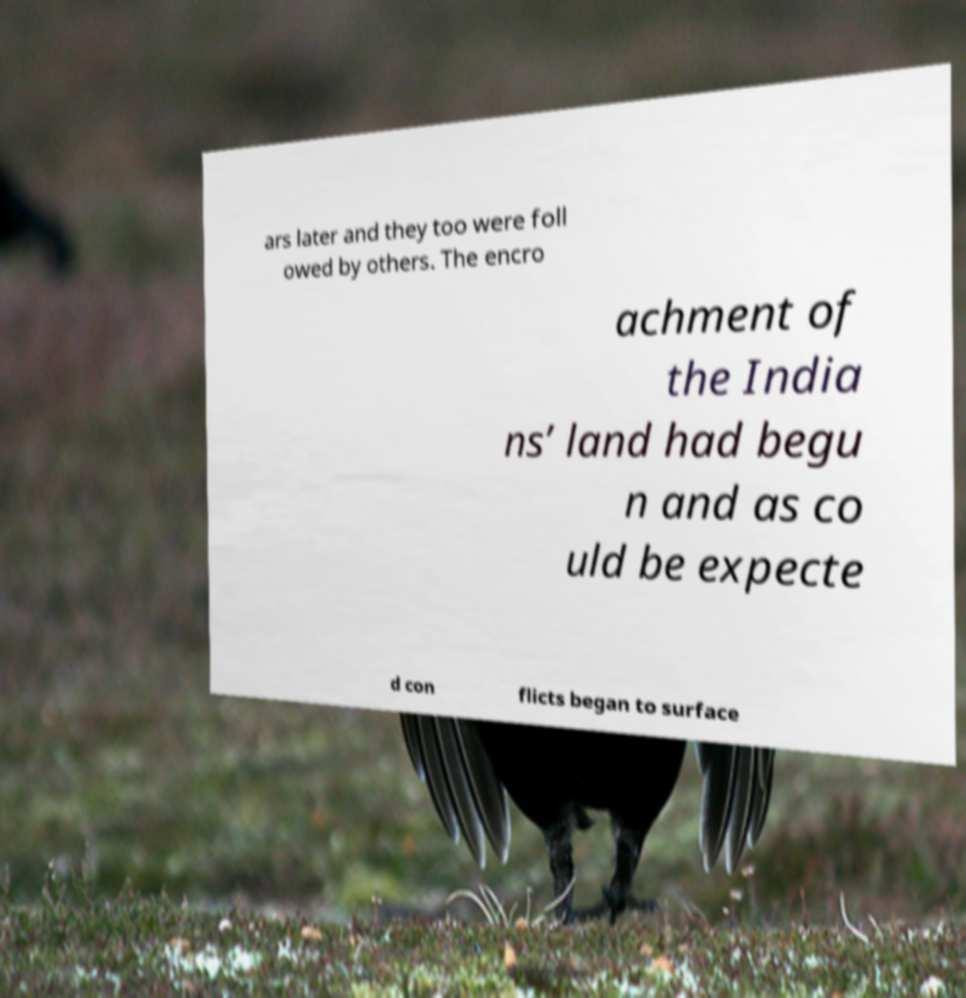Could you extract and type out the text from this image? ars later and they too were foll owed by others. The encro achment of the India ns’ land had begu n and as co uld be expecte d con flicts began to surface 